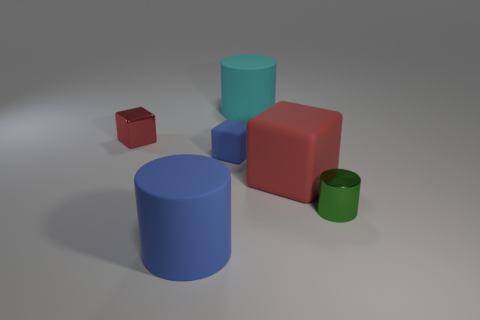How many things are either blue objects or tiny brown matte cylinders?
Give a very brief answer. 2. Is there a small green cylinder to the left of the blue object in front of the small metal cylinder?
Offer a terse response. No. Is the number of things right of the cyan rubber object greater than the number of tiny metal blocks on the right side of the blue rubber block?
Your answer should be compact. Yes. What material is the cylinder that is the same color as the tiny rubber cube?
Ensure brevity in your answer.  Rubber. What number of metal things have the same color as the large cube?
Keep it short and to the point. 1. There is a big matte cylinder in front of the big red block; is its color the same as the shiny thing that is on the right side of the cyan thing?
Ensure brevity in your answer.  No. There is a big cyan cylinder; are there any small matte objects in front of it?
Give a very brief answer. Yes. What is the material of the large blue thing?
Offer a very short reply. Rubber. There is a blue thing behind the big blue cylinder; what is its shape?
Provide a short and direct response. Cube. The other object that is the same color as the small matte thing is what size?
Ensure brevity in your answer.  Large. 